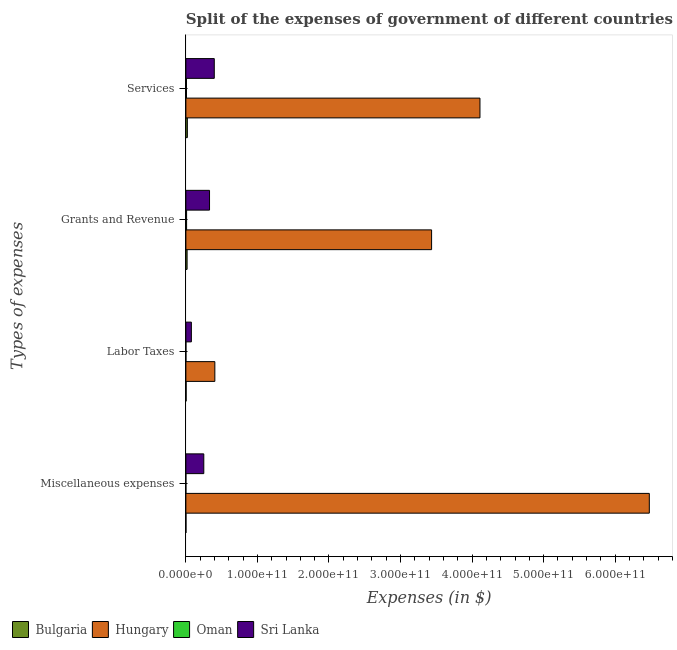How many groups of bars are there?
Provide a short and direct response. 4. What is the label of the 2nd group of bars from the top?
Your answer should be very brief. Grants and Revenue. What is the amount spent on services in Sri Lanka?
Offer a very short reply. 3.97e+1. Across all countries, what is the maximum amount spent on grants and revenue?
Your response must be concise. 3.43e+11. Across all countries, what is the minimum amount spent on labor taxes?
Your answer should be compact. 4.32e+07. In which country was the amount spent on services maximum?
Your response must be concise. Hungary. In which country was the amount spent on services minimum?
Keep it short and to the point. Oman. What is the total amount spent on grants and revenue in the graph?
Offer a terse response. 3.79e+11. What is the difference between the amount spent on labor taxes in Sri Lanka and that in Hungary?
Make the answer very short. -3.28e+1. What is the difference between the amount spent on labor taxes in Oman and the amount spent on services in Sri Lanka?
Your answer should be compact. -3.96e+1. What is the average amount spent on grants and revenue per country?
Offer a very short reply. 9.48e+1. What is the difference between the amount spent on miscellaneous expenses and amount spent on services in Sri Lanka?
Your answer should be compact. -1.46e+1. In how many countries, is the amount spent on miscellaneous expenses greater than 200000000000 $?
Offer a very short reply. 1. What is the ratio of the amount spent on miscellaneous expenses in Sri Lanka to that in Oman?
Your answer should be very brief. 1.39e+04. What is the difference between the highest and the second highest amount spent on labor taxes?
Make the answer very short. 3.28e+1. What is the difference between the highest and the lowest amount spent on services?
Provide a succinct answer. 4.10e+11. What does the 3rd bar from the top in Labor Taxes represents?
Provide a succinct answer. Hungary. What does the 1st bar from the bottom in Miscellaneous expenses represents?
Provide a succinct answer. Bulgaria. Is it the case that in every country, the sum of the amount spent on miscellaneous expenses and amount spent on labor taxes is greater than the amount spent on grants and revenue?
Offer a very short reply. No. How many countries are there in the graph?
Make the answer very short. 4. What is the difference between two consecutive major ticks on the X-axis?
Offer a terse response. 1.00e+11. Does the graph contain any zero values?
Give a very brief answer. No. Where does the legend appear in the graph?
Give a very brief answer. Bottom left. What is the title of the graph?
Offer a terse response. Split of the expenses of government of different countries in 1999. Does "Kyrgyz Republic" appear as one of the legend labels in the graph?
Offer a very short reply. No. What is the label or title of the X-axis?
Provide a short and direct response. Expenses (in $). What is the label or title of the Y-axis?
Make the answer very short. Types of expenses. What is the Expenses (in $) in Bulgaria in Miscellaneous expenses?
Keep it short and to the point. 1.36e+08. What is the Expenses (in $) in Hungary in Miscellaneous expenses?
Offer a terse response. 6.48e+11. What is the Expenses (in $) in Oman in Miscellaneous expenses?
Ensure brevity in your answer.  1.80e+06. What is the Expenses (in $) in Sri Lanka in Miscellaneous expenses?
Your answer should be very brief. 2.50e+1. What is the Expenses (in $) of Bulgaria in Labor Taxes?
Keep it short and to the point. 3.39e+08. What is the Expenses (in $) of Hungary in Labor Taxes?
Your answer should be very brief. 4.05e+1. What is the Expenses (in $) of Oman in Labor Taxes?
Keep it short and to the point. 4.32e+07. What is the Expenses (in $) of Sri Lanka in Labor Taxes?
Your answer should be compact. 7.69e+09. What is the Expenses (in $) in Bulgaria in Grants and Revenue?
Your answer should be compact. 1.70e+09. What is the Expenses (in $) in Hungary in Grants and Revenue?
Your answer should be very brief. 3.43e+11. What is the Expenses (in $) in Oman in Grants and Revenue?
Provide a short and direct response. 9.96e+08. What is the Expenses (in $) of Sri Lanka in Grants and Revenue?
Offer a very short reply. 3.31e+1. What is the Expenses (in $) of Bulgaria in Services?
Offer a very short reply. 2.07e+09. What is the Expenses (in $) of Hungary in Services?
Your answer should be very brief. 4.11e+11. What is the Expenses (in $) of Oman in Services?
Your answer should be very brief. 8.49e+08. What is the Expenses (in $) in Sri Lanka in Services?
Keep it short and to the point. 3.97e+1. Across all Types of expenses, what is the maximum Expenses (in $) in Bulgaria?
Ensure brevity in your answer.  2.07e+09. Across all Types of expenses, what is the maximum Expenses (in $) of Hungary?
Ensure brevity in your answer.  6.48e+11. Across all Types of expenses, what is the maximum Expenses (in $) in Oman?
Your response must be concise. 9.96e+08. Across all Types of expenses, what is the maximum Expenses (in $) of Sri Lanka?
Give a very brief answer. 3.97e+1. Across all Types of expenses, what is the minimum Expenses (in $) of Bulgaria?
Keep it short and to the point. 1.36e+08. Across all Types of expenses, what is the minimum Expenses (in $) of Hungary?
Ensure brevity in your answer.  4.05e+1. Across all Types of expenses, what is the minimum Expenses (in $) of Oman?
Give a very brief answer. 1.80e+06. Across all Types of expenses, what is the minimum Expenses (in $) of Sri Lanka?
Make the answer very short. 7.69e+09. What is the total Expenses (in $) of Bulgaria in the graph?
Keep it short and to the point. 4.25e+09. What is the total Expenses (in $) of Hungary in the graph?
Give a very brief answer. 1.44e+12. What is the total Expenses (in $) of Oman in the graph?
Provide a short and direct response. 1.89e+09. What is the total Expenses (in $) in Sri Lanka in the graph?
Offer a very short reply. 1.05e+11. What is the difference between the Expenses (in $) of Bulgaria in Miscellaneous expenses and that in Labor Taxes?
Your response must be concise. -2.03e+08. What is the difference between the Expenses (in $) of Hungary in Miscellaneous expenses and that in Labor Taxes?
Provide a short and direct response. 6.07e+11. What is the difference between the Expenses (in $) in Oman in Miscellaneous expenses and that in Labor Taxes?
Ensure brevity in your answer.  -4.14e+07. What is the difference between the Expenses (in $) of Sri Lanka in Miscellaneous expenses and that in Labor Taxes?
Ensure brevity in your answer.  1.74e+1. What is the difference between the Expenses (in $) of Bulgaria in Miscellaneous expenses and that in Grants and Revenue?
Ensure brevity in your answer.  -1.57e+09. What is the difference between the Expenses (in $) in Hungary in Miscellaneous expenses and that in Grants and Revenue?
Your answer should be compact. 3.04e+11. What is the difference between the Expenses (in $) of Oman in Miscellaneous expenses and that in Grants and Revenue?
Your answer should be very brief. -9.94e+08. What is the difference between the Expenses (in $) of Sri Lanka in Miscellaneous expenses and that in Grants and Revenue?
Give a very brief answer. -8.02e+09. What is the difference between the Expenses (in $) of Bulgaria in Miscellaneous expenses and that in Services?
Your answer should be compact. -1.93e+09. What is the difference between the Expenses (in $) of Hungary in Miscellaneous expenses and that in Services?
Your answer should be very brief. 2.37e+11. What is the difference between the Expenses (in $) of Oman in Miscellaneous expenses and that in Services?
Ensure brevity in your answer.  -8.47e+08. What is the difference between the Expenses (in $) in Sri Lanka in Miscellaneous expenses and that in Services?
Provide a short and direct response. -1.46e+1. What is the difference between the Expenses (in $) of Bulgaria in Labor Taxes and that in Grants and Revenue?
Make the answer very short. -1.36e+09. What is the difference between the Expenses (in $) in Hungary in Labor Taxes and that in Grants and Revenue?
Give a very brief answer. -3.03e+11. What is the difference between the Expenses (in $) of Oman in Labor Taxes and that in Grants and Revenue?
Your answer should be very brief. -9.53e+08. What is the difference between the Expenses (in $) of Sri Lanka in Labor Taxes and that in Grants and Revenue?
Provide a short and direct response. -2.54e+1. What is the difference between the Expenses (in $) of Bulgaria in Labor Taxes and that in Services?
Your answer should be very brief. -1.73e+09. What is the difference between the Expenses (in $) of Hungary in Labor Taxes and that in Services?
Give a very brief answer. -3.71e+11. What is the difference between the Expenses (in $) in Oman in Labor Taxes and that in Services?
Offer a very short reply. -8.06e+08. What is the difference between the Expenses (in $) in Sri Lanka in Labor Taxes and that in Services?
Give a very brief answer. -3.20e+1. What is the difference between the Expenses (in $) in Bulgaria in Grants and Revenue and that in Services?
Ensure brevity in your answer.  -3.64e+08. What is the difference between the Expenses (in $) in Hungary in Grants and Revenue and that in Services?
Provide a succinct answer. -6.76e+1. What is the difference between the Expenses (in $) in Oman in Grants and Revenue and that in Services?
Provide a short and direct response. 1.47e+08. What is the difference between the Expenses (in $) of Sri Lanka in Grants and Revenue and that in Services?
Offer a terse response. -6.62e+09. What is the difference between the Expenses (in $) of Bulgaria in Miscellaneous expenses and the Expenses (in $) of Hungary in Labor Taxes?
Ensure brevity in your answer.  -4.03e+1. What is the difference between the Expenses (in $) of Bulgaria in Miscellaneous expenses and the Expenses (in $) of Oman in Labor Taxes?
Your answer should be compact. 9.31e+07. What is the difference between the Expenses (in $) of Bulgaria in Miscellaneous expenses and the Expenses (in $) of Sri Lanka in Labor Taxes?
Your response must be concise. -7.55e+09. What is the difference between the Expenses (in $) in Hungary in Miscellaneous expenses and the Expenses (in $) in Oman in Labor Taxes?
Offer a very short reply. 6.48e+11. What is the difference between the Expenses (in $) in Hungary in Miscellaneous expenses and the Expenses (in $) in Sri Lanka in Labor Taxes?
Your response must be concise. 6.40e+11. What is the difference between the Expenses (in $) in Oman in Miscellaneous expenses and the Expenses (in $) in Sri Lanka in Labor Taxes?
Provide a short and direct response. -7.69e+09. What is the difference between the Expenses (in $) in Bulgaria in Miscellaneous expenses and the Expenses (in $) in Hungary in Grants and Revenue?
Your answer should be compact. -3.43e+11. What is the difference between the Expenses (in $) of Bulgaria in Miscellaneous expenses and the Expenses (in $) of Oman in Grants and Revenue?
Make the answer very short. -8.60e+08. What is the difference between the Expenses (in $) of Bulgaria in Miscellaneous expenses and the Expenses (in $) of Sri Lanka in Grants and Revenue?
Make the answer very short. -3.29e+1. What is the difference between the Expenses (in $) of Hungary in Miscellaneous expenses and the Expenses (in $) of Oman in Grants and Revenue?
Your answer should be compact. 6.47e+11. What is the difference between the Expenses (in $) of Hungary in Miscellaneous expenses and the Expenses (in $) of Sri Lanka in Grants and Revenue?
Your answer should be compact. 6.15e+11. What is the difference between the Expenses (in $) of Oman in Miscellaneous expenses and the Expenses (in $) of Sri Lanka in Grants and Revenue?
Ensure brevity in your answer.  -3.31e+1. What is the difference between the Expenses (in $) in Bulgaria in Miscellaneous expenses and the Expenses (in $) in Hungary in Services?
Ensure brevity in your answer.  -4.11e+11. What is the difference between the Expenses (in $) of Bulgaria in Miscellaneous expenses and the Expenses (in $) of Oman in Services?
Your response must be concise. -7.13e+08. What is the difference between the Expenses (in $) in Bulgaria in Miscellaneous expenses and the Expenses (in $) in Sri Lanka in Services?
Provide a short and direct response. -3.96e+1. What is the difference between the Expenses (in $) in Hungary in Miscellaneous expenses and the Expenses (in $) in Oman in Services?
Offer a very short reply. 6.47e+11. What is the difference between the Expenses (in $) in Hungary in Miscellaneous expenses and the Expenses (in $) in Sri Lanka in Services?
Keep it short and to the point. 6.08e+11. What is the difference between the Expenses (in $) of Oman in Miscellaneous expenses and the Expenses (in $) of Sri Lanka in Services?
Your response must be concise. -3.97e+1. What is the difference between the Expenses (in $) of Bulgaria in Labor Taxes and the Expenses (in $) of Hungary in Grants and Revenue?
Your answer should be very brief. -3.43e+11. What is the difference between the Expenses (in $) in Bulgaria in Labor Taxes and the Expenses (in $) in Oman in Grants and Revenue?
Offer a terse response. -6.57e+08. What is the difference between the Expenses (in $) of Bulgaria in Labor Taxes and the Expenses (in $) of Sri Lanka in Grants and Revenue?
Offer a very short reply. -3.27e+1. What is the difference between the Expenses (in $) of Hungary in Labor Taxes and the Expenses (in $) of Oman in Grants and Revenue?
Provide a succinct answer. 3.95e+1. What is the difference between the Expenses (in $) of Hungary in Labor Taxes and the Expenses (in $) of Sri Lanka in Grants and Revenue?
Provide a succinct answer. 7.41e+09. What is the difference between the Expenses (in $) of Oman in Labor Taxes and the Expenses (in $) of Sri Lanka in Grants and Revenue?
Ensure brevity in your answer.  -3.30e+1. What is the difference between the Expenses (in $) in Bulgaria in Labor Taxes and the Expenses (in $) in Hungary in Services?
Offer a very short reply. -4.11e+11. What is the difference between the Expenses (in $) of Bulgaria in Labor Taxes and the Expenses (in $) of Oman in Services?
Ensure brevity in your answer.  -5.10e+08. What is the difference between the Expenses (in $) in Bulgaria in Labor Taxes and the Expenses (in $) in Sri Lanka in Services?
Offer a terse response. -3.94e+1. What is the difference between the Expenses (in $) of Hungary in Labor Taxes and the Expenses (in $) of Oman in Services?
Give a very brief answer. 3.96e+1. What is the difference between the Expenses (in $) of Hungary in Labor Taxes and the Expenses (in $) of Sri Lanka in Services?
Provide a succinct answer. 7.84e+08. What is the difference between the Expenses (in $) in Oman in Labor Taxes and the Expenses (in $) in Sri Lanka in Services?
Give a very brief answer. -3.96e+1. What is the difference between the Expenses (in $) of Bulgaria in Grants and Revenue and the Expenses (in $) of Hungary in Services?
Your response must be concise. -4.09e+11. What is the difference between the Expenses (in $) of Bulgaria in Grants and Revenue and the Expenses (in $) of Oman in Services?
Give a very brief answer. 8.54e+08. What is the difference between the Expenses (in $) in Bulgaria in Grants and Revenue and the Expenses (in $) in Sri Lanka in Services?
Your response must be concise. -3.80e+1. What is the difference between the Expenses (in $) of Hungary in Grants and Revenue and the Expenses (in $) of Oman in Services?
Provide a short and direct response. 3.43e+11. What is the difference between the Expenses (in $) in Hungary in Grants and Revenue and the Expenses (in $) in Sri Lanka in Services?
Offer a very short reply. 3.04e+11. What is the difference between the Expenses (in $) in Oman in Grants and Revenue and the Expenses (in $) in Sri Lanka in Services?
Keep it short and to the point. -3.87e+1. What is the average Expenses (in $) of Bulgaria per Types of expenses?
Offer a terse response. 1.06e+09. What is the average Expenses (in $) in Hungary per Types of expenses?
Ensure brevity in your answer.  3.61e+11. What is the average Expenses (in $) in Oman per Types of expenses?
Your answer should be compact. 4.73e+08. What is the average Expenses (in $) in Sri Lanka per Types of expenses?
Your answer should be very brief. 2.64e+1. What is the difference between the Expenses (in $) in Bulgaria and Expenses (in $) in Hungary in Miscellaneous expenses?
Offer a very short reply. -6.48e+11. What is the difference between the Expenses (in $) of Bulgaria and Expenses (in $) of Oman in Miscellaneous expenses?
Offer a terse response. 1.35e+08. What is the difference between the Expenses (in $) of Bulgaria and Expenses (in $) of Sri Lanka in Miscellaneous expenses?
Offer a very short reply. -2.49e+1. What is the difference between the Expenses (in $) in Hungary and Expenses (in $) in Oman in Miscellaneous expenses?
Ensure brevity in your answer.  6.48e+11. What is the difference between the Expenses (in $) in Hungary and Expenses (in $) in Sri Lanka in Miscellaneous expenses?
Provide a succinct answer. 6.23e+11. What is the difference between the Expenses (in $) of Oman and Expenses (in $) of Sri Lanka in Miscellaneous expenses?
Provide a succinct answer. -2.50e+1. What is the difference between the Expenses (in $) in Bulgaria and Expenses (in $) in Hungary in Labor Taxes?
Make the answer very short. -4.01e+1. What is the difference between the Expenses (in $) of Bulgaria and Expenses (in $) of Oman in Labor Taxes?
Keep it short and to the point. 2.96e+08. What is the difference between the Expenses (in $) in Bulgaria and Expenses (in $) in Sri Lanka in Labor Taxes?
Provide a short and direct response. -7.35e+09. What is the difference between the Expenses (in $) of Hungary and Expenses (in $) of Oman in Labor Taxes?
Your answer should be compact. 4.04e+1. What is the difference between the Expenses (in $) in Hungary and Expenses (in $) in Sri Lanka in Labor Taxes?
Ensure brevity in your answer.  3.28e+1. What is the difference between the Expenses (in $) in Oman and Expenses (in $) in Sri Lanka in Labor Taxes?
Offer a terse response. -7.65e+09. What is the difference between the Expenses (in $) of Bulgaria and Expenses (in $) of Hungary in Grants and Revenue?
Offer a very short reply. -3.42e+11. What is the difference between the Expenses (in $) in Bulgaria and Expenses (in $) in Oman in Grants and Revenue?
Make the answer very short. 7.07e+08. What is the difference between the Expenses (in $) of Bulgaria and Expenses (in $) of Sri Lanka in Grants and Revenue?
Your answer should be compact. -3.14e+1. What is the difference between the Expenses (in $) of Hungary and Expenses (in $) of Oman in Grants and Revenue?
Offer a very short reply. 3.42e+11. What is the difference between the Expenses (in $) of Hungary and Expenses (in $) of Sri Lanka in Grants and Revenue?
Provide a succinct answer. 3.10e+11. What is the difference between the Expenses (in $) in Oman and Expenses (in $) in Sri Lanka in Grants and Revenue?
Provide a short and direct response. -3.21e+1. What is the difference between the Expenses (in $) of Bulgaria and Expenses (in $) of Hungary in Services?
Provide a short and direct response. -4.09e+11. What is the difference between the Expenses (in $) in Bulgaria and Expenses (in $) in Oman in Services?
Offer a very short reply. 1.22e+09. What is the difference between the Expenses (in $) in Bulgaria and Expenses (in $) in Sri Lanka in Services?
Give a very brief answer. -3.76e+1. What is the difference between the Expenses (in $) in Hungary and Expenses (in $) in Oman in Services?
Give a very brief answer. 4.10e+11. What is the difference between the Expenses (in $) in Hungary and Expenses (in $) in Sri Lanka in Services?
Give a very brief answer. 3.71e+11. What is the difference between the Expenses (in $) of Oman and Expenses (in $) of Sri Lanka in Services?
Offer a terse response. -3.88e+1. What is the ratio of the Expenses (in $) in Bulgaria in Miscellaneous expenses to that in Labor Taxes?
Provide a succinct answer. 0.4. What is the ratio of the Expenses (in $) of Hungary in Miscellaneous expenses to that in Labor Taxes?
Your answer should be very brief. 16. What is the ratio of the Expenses (in $) of Oman in Miscellaneous expenses to that in Labor Taxes?
Provide a succinct answer. 0.04. What is the ratio of the Expenses (in $) of Sri Lanka in Miscellaneous expenses to that in Labor Taxes?
Provide a short and direct response. 3.26. What is the ratio of the Expenses (in $) in Bulgaria in Miscellaneous expenses to that in Grants and Revenue?
Keep it short and to the point. 0.08. What is the ratio of the Expenses (in $) in Hungary in Miscellaneous expenses to that in Grants and Revenue?
Your answer should be compact. 1.89. What is the ratio of the Expenses (in $) of Oman in Miscellaneous expenses to that in Grants and Revenue?
Make the answer very short. 0. What is the ratio of the Expenses (in $) of Sri Lanka in Miscellaneous expenses to that in Grants and Revenue?
Make the answer very short. 0.76. What is the ratio of the Expenses (in $) in Bulgaria in Miscellaneous expenses to that in Services?
Keep it short and to the point. 0.07. What is the ratio of the Expenses (in $) in Hungary in Miscellaneous expenses to that in Services?
Give a very brief answer. 1.58. What is the ratio of the Expenses (in $) in Oman in Miscellaneous expenses to that in Services?
Your answer should be very brief. 0. What is the ratio of the Expenses (in $) in Sri Lanka in Miscellaneous expenses to that in Services?
Make the answer very short. 0.63. What is the ratio of the Expenses (in $) in Bulgaria in Labor Taxes to that in Grants and Revenue?
Your answer should be compact. 0.2. What is the ratio of the Expenses (in $) in Hungary in Labor Taxes to that in Grants and Revenue?
Your response must be concise. 0.12. What is the ratio of the Expenses (in $) in Oman in Labor Taxes to that in Grants and Revenue?
Offer a very short reply. 0.04. What is the ratio of the Expenses (in $) of Sri Lanka in Labor Taxes to that in Grants and Revenue?
Give a very brief answer. 0.23. What is the ratio of the Expenses (in $) in Bulgaria in Labor Taxes to that in Services?
Make the answer very short. 0.16. What is the ratio of the Expenses (in $) of Hungary in Labor Taxes to that in Services?
Make the answer very short. 0.1. What is the ratio of the Expenses (in $) in Oman in Labor Taxes to that in Services?
Keep it short and to the point. 0.05. What is the ratio of the Expenses (in $) of Sri Lanka in Labor Taxes to that in Services?
Your answer should be very brief. 0.19. What is the ratio of the Expenses (in $) in Bulgaria in Grants and Revenue to that in Services?
Provide a succinct answer. 0.82. What is the ratio of the Expenses (in $) in Hungary in Grants and Revenue to that in Services?
Provide a succinct answer. 0.84. What is the ratio of the Expenses (in $) of Oman in Grants and Revenue to that in Services?
Provide a succinct answer. 1.17. What is the ratio of the Expenses (in $) of Sri Lanka in Grants and Revenue to that in Services?
Ensure brevity in your answer.  0.83. What is the difference between the highest and the second highest Expenses (in $) in Bulgaria?
Ensure brevity in your answer.  3.64e+08. What is the difference between the highest and the second highest Expenses (in $) of Hungary?
Offer a terse response. 2.37e+11. What is the difference between the highest and the second highest Expenses (in $) in Oman?
Keep it short and to the point. 1.47e+08. What is the difference between the highest and the second highest Expenses (in $) in Sri Lanka?
Ensure brevity in your answer.  6.62e+09. What is the difference between the highest and the lowest Expenses (in $) of Bulgaria?
Provide a succinct answer. 1.93e+09. What is the difference between the highest and the lowest Expenses (in $) in Hungary?
Keep it short and to the point. 6.07e+11. What is the difference between the highest and the lowest Expenses (in $) of Oman?
Your answer should be compact. 9.94e+08. What is the difference between the highest and the lowest Expenses (in $) in Sri Lanka?
Offer a very short reply. 3.20e+1. 